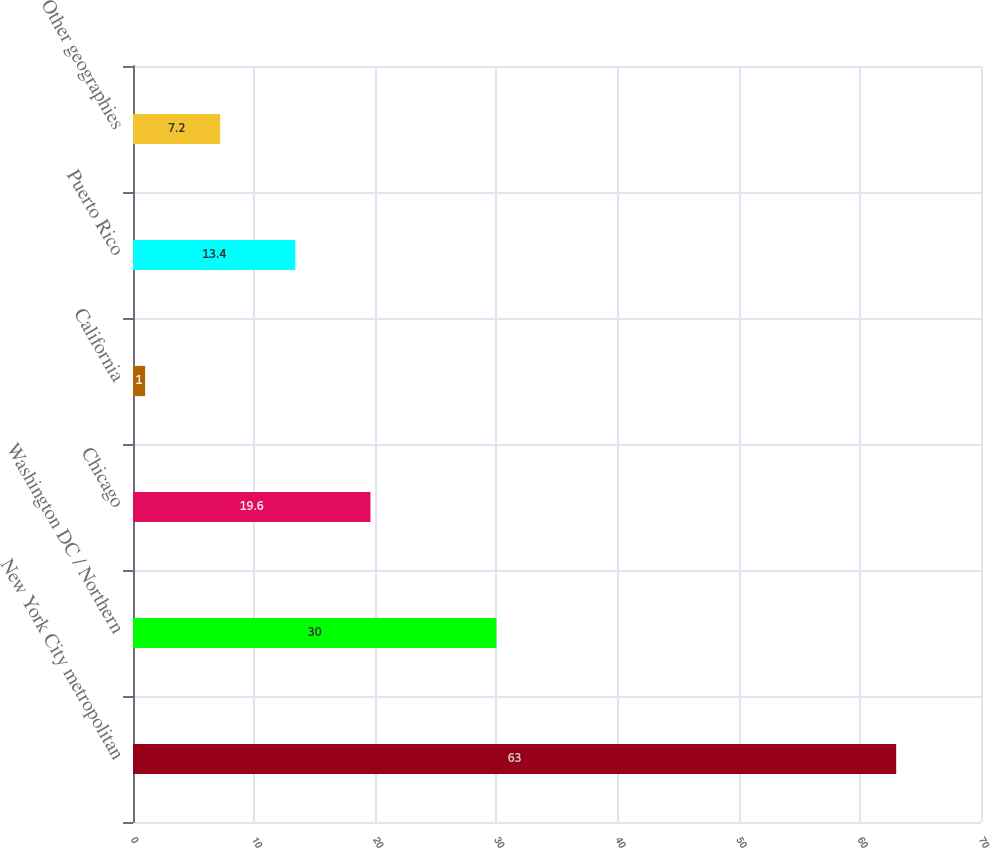<chart> <loc_0><loc_0><loc_500><loc_500><bar_chart><fcel>New York City metropolitan<fcel>Washington DC / Northern<fcel>Chicago<fcel>California<fcel>Puerto Rico<fcel>Other geographies<nl><fcel>63<fcel>30<fcel>19.6<fcel>1<fcel>13.4<fcel>7.2<nl></chart> 